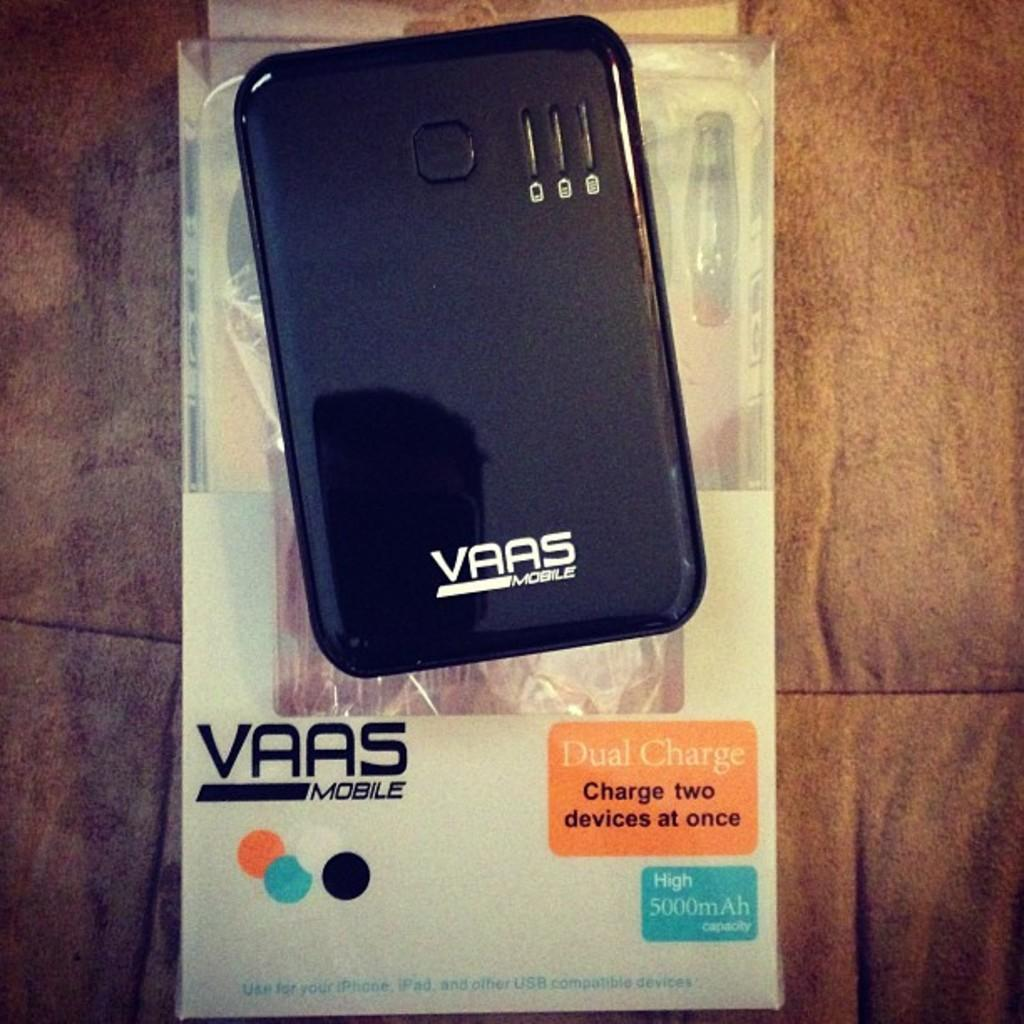What is the color of the mobile in the image? The mobile in the image is black. What is written on the mobile? The mobile has "vaas mobile" written on it. What is located under the mobile in the image? There is a box under the mobile in the image. Where can we find the nearest shop to buy a hat in the image? There is no shop or hat present in the image. 